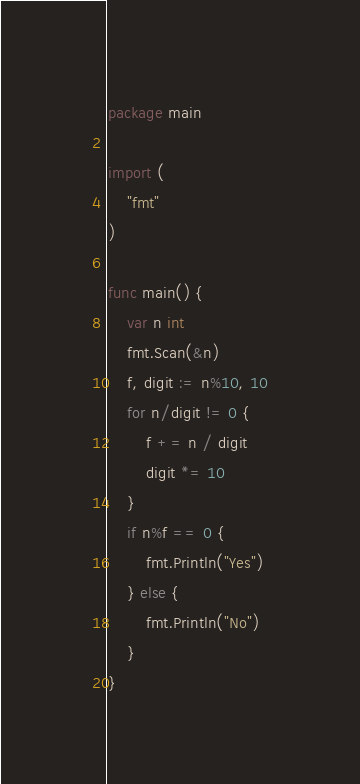Convert code to text. <code><loc_0><loc_0><loc_500><loc_500><_Go_>package main

import (
	"fmt"
)

func main() {
	var n int
	fmt.Scan(&n)
	f, digit := n%10, 10
	for n/digit != 0 {
		f += n / digit
		digit *= 10
	}
	if n%f == 0 {
		fmt.Println("Yes")
	} else {
		fmt.Println("No")
	}
}</code> 